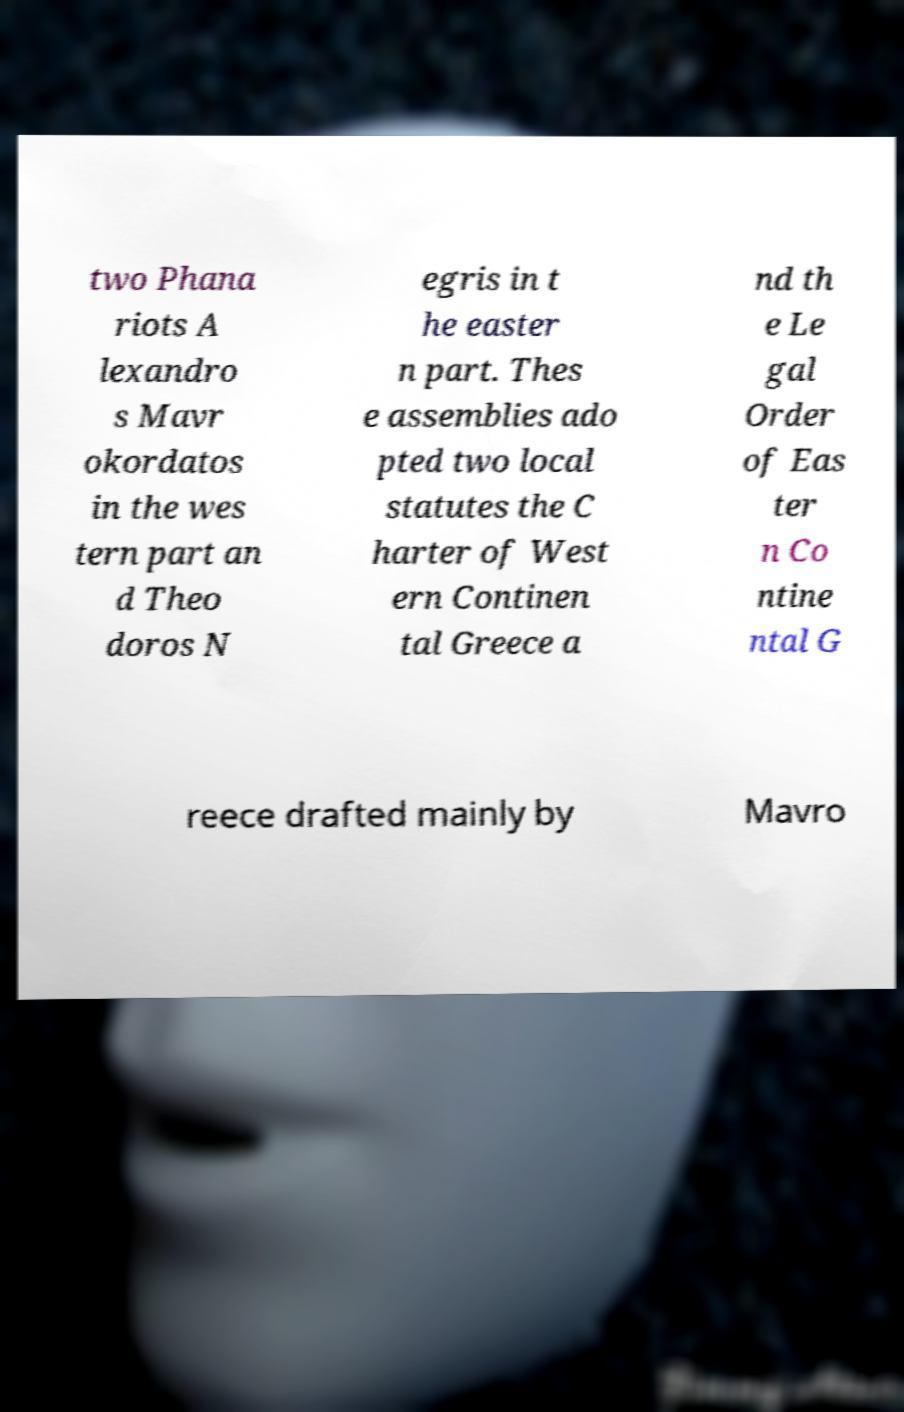For documentation purposes, I need the text within this image transcribed. Could you provide that? two Phana riots A lexandro s Mavr okordatos in the wes tern part an d Theo doros N egris in t he easter n part. Thes e assemblies ado pted two local statutes the C harter of West ern Continen tal Greece a nd th e Le gal Order of Eas ter n Co ntine ntal G reece drafted mainly by Mavro 